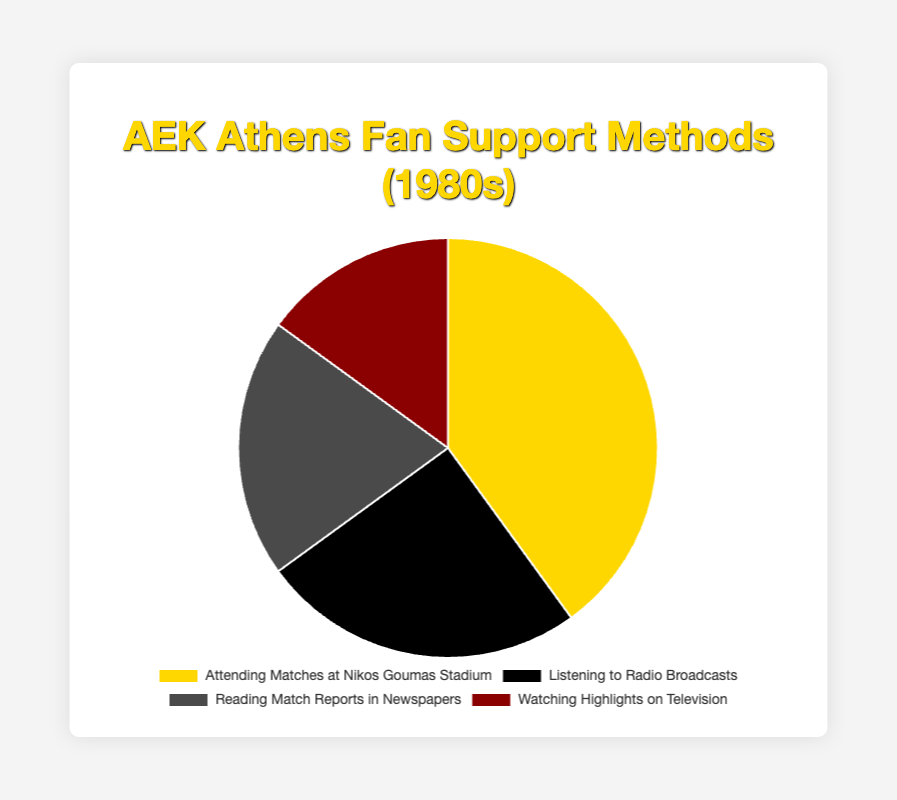Which method of supporting AEK Athens was the most preferred by the fans in the 1980s? The most preferred method is indicated by the largest segment of the pie chart. "Attending Matches at Nikos Goumas Stadium" has the largest segment at 40%.
Answer: Attending Matches at Nikos Goumas Stadium Compare the percentage of fans who preferred listening to radio broadcasts versus reading match reports in newspapers. Which was higher? Looking at the relative sizes of the pie chart segments, "Listening to Radio Broadcasts" is 25% whereas "Reading Match Reports in Newspapers" is 20%.
Answer: Listening to Radio Broadcasts What is the sum of the percentages for listening to radio broadcasts and watching highlights on television? Add the percentages of "Listening to Radio Broadcasts" (25%) and "Watching Highlights on Television" (15%). The sum is 25% + 15% = 40%.
Answer: 40% Which supporting method had the smallest percentage of fans? The smallest segment visible on the pie chart represents "Watching Highlights on Television" with a percentage of 15%.
Answer: Watching Highlights on Television Is the percentage of fans who preferred reading match reports in newspapers greater than or equal to the percentage who preferred watching highlights on television? Compare the percentages: "Reading Match Reports in Newspapers" is 20%, and "Watching Highlights on Television" is 15%. 20% is greater than 15%.
Answer: Greater What is the difference in percentage between the most preferred and the least preferred supporting methods? Subtract the least preferred method's percentage (15% for "Watching Highlights on Television") from the most preferred method's percentage (40% for "Attending Matches at Nikos Goumas Stadium"). 40% - 15% = 25%.
Answer: 25% Which method is represented by a black segment in the pie chart? The visual property of the segment having a black color corresponds to "Listening to Radio Broadcasts."
Answer: Listening to Radio Broadcasts What percentage of fans preferred methods other than attending matches at Nikos Goumas Stadium? To find the percentage of fans who preferred the other methods, add the percentages of the other slices: 25% (Radio) + 20% (Newspapers) + 15% (Television) = 60%.
Answer: 60% What is the average percentage of fans per method for all four supporting methods? Add all percentages: 40% + 25% + 20% + 15% = 100%. Divide by the number of methods (4): 100% / 4 = 25%.
Answer: 25% Compare the total percentages of remote methods (listening to radio broadcasts, reading match reports in newspapers, and watching highlights on television) versus attending matches. Which is higher? The remote methods sum up to 25% (Radio) + 20% (Newspapers) + 15% (Television) = 60%. Comparing this to 40% for attending matches, 60% is higher.
Answer: Remote Methods 